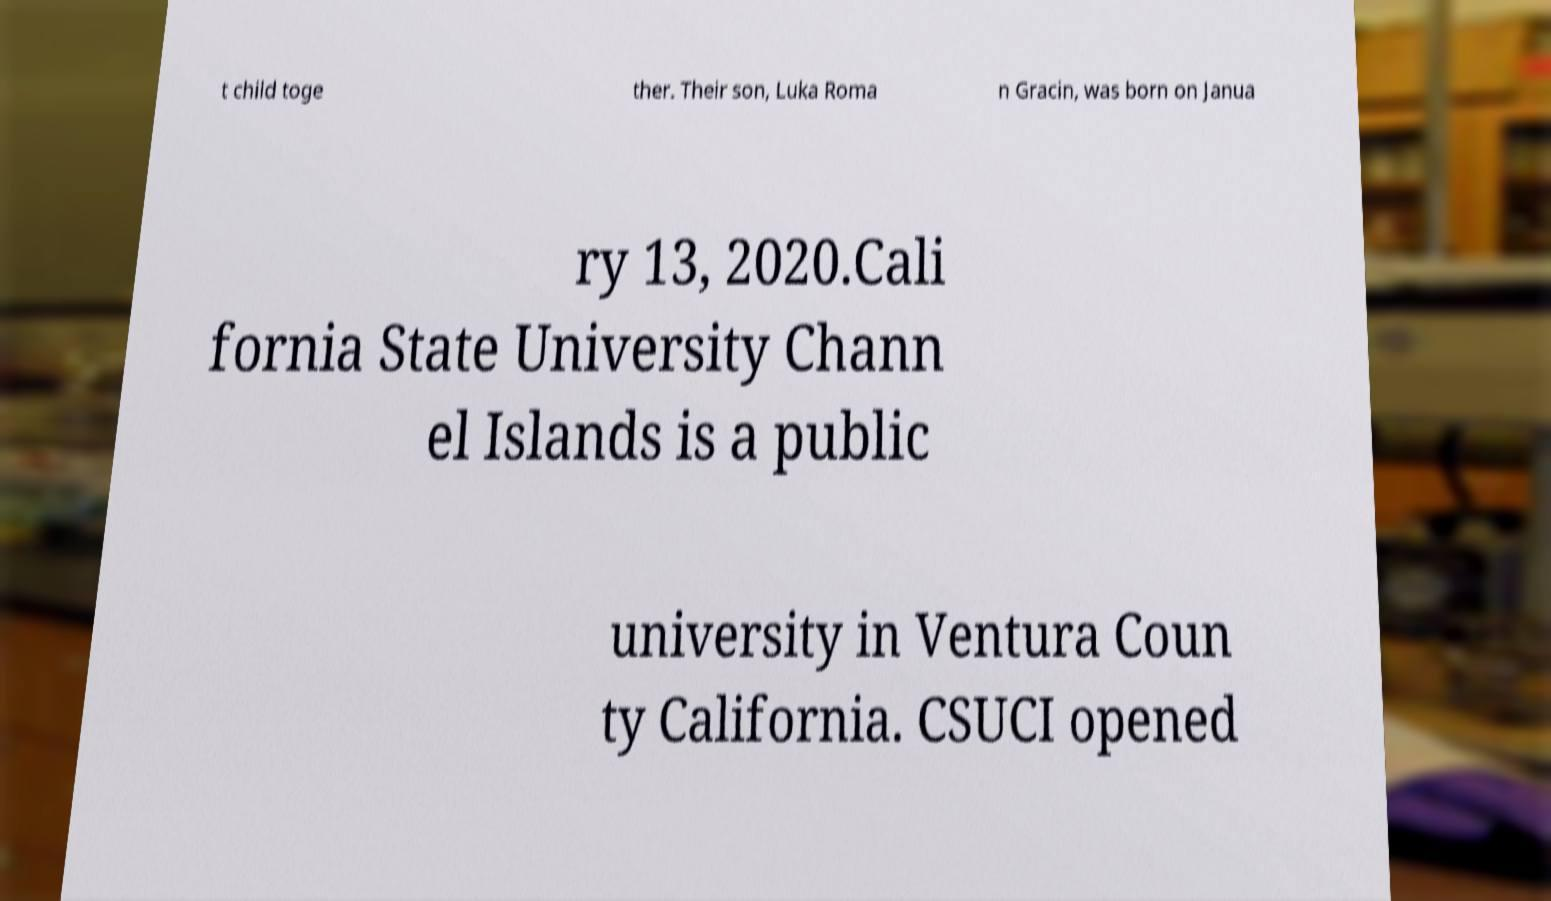For documentation purposes, I need the text within this image transcribed. Could you provide that? t child toge ther. Their son, Luka Roma n Gracin, was born on Janua ry 13, 2020.Cali fornia State University Chann el Islands is a public university in Ventura Coun ty California. CSUCI opened 